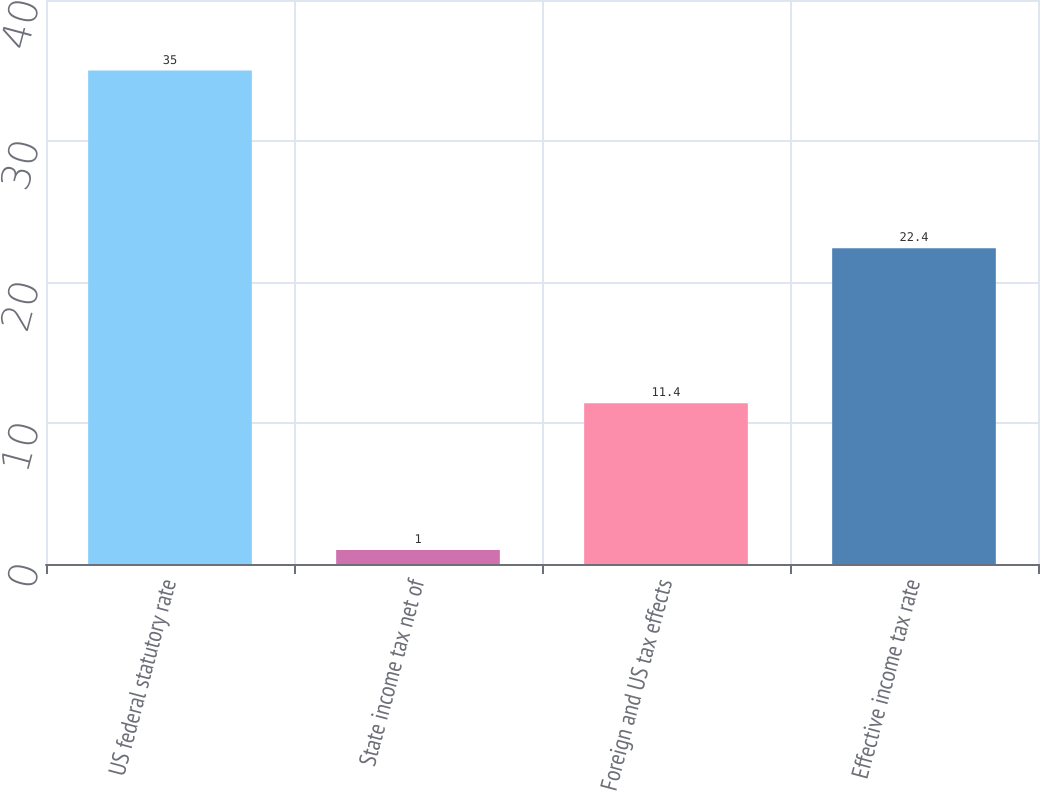Convert chart to OTSL. <chart><loc_0><loc_0><loc_500><loc_500><bar_chart><fcel>US federal statutory rate<fcel>State income tax net of<fcel>Foreign and US tax effects<fcel>Effective income tax rate<nl><fcel>35<fcel>1<fcel>11.4<fcel>22.4<nl></chart> 